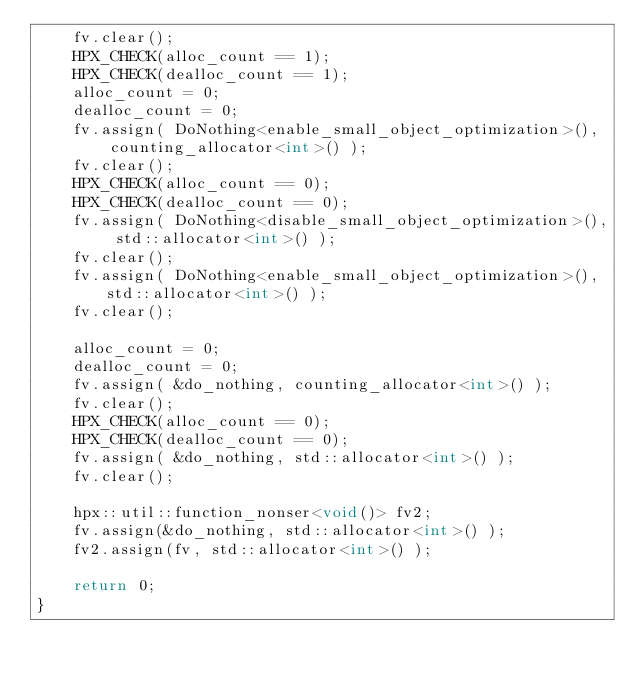<code> <loc_0><loc_0><loc_500><loc_500><_C++_>    fv.clear();
    HPX_CHECK(alloc_count == 1);
    HPX_CHECK(dealloc_count == 1);
    alloc_count = 0;
    dealloc_count = 0;
    fv.assign( DoNothing<enable_small_object_optimization>(),
        counting_allocator<int>() );
    fv.clear();
    HPX_CHECK(alloc_count == 0);
    HPX_CHECK(dealloc_count == 0);
    fv.assign( DoNothing<disable_small_object_optimization>(), std::allocator<int>() );
    fv.clear();
    fv.assign( DoNothing<enable_small_object_optimization>(), std::allocator<int>() );
    fv.clear();

    alloc_count = 0;
    dealloc_count = 0;
    fv.assign( &do_nothing, counting_allocator<int>() );
    fv.clear();
    HPX_CHECK(alloc_count == 0);
    HPX_CHECK(dealloc_count == 0);
    fv.assign( &do_nothing, std::allocator<int>() );
    fv.clear();

    hpx::util::function_nonser<void()> fv2;
    fv.assign(&do_nothing, std::allocator<int>() );
    fv2.assign(fv, std::allocator<int>() );

    return 0;
}
</code> 